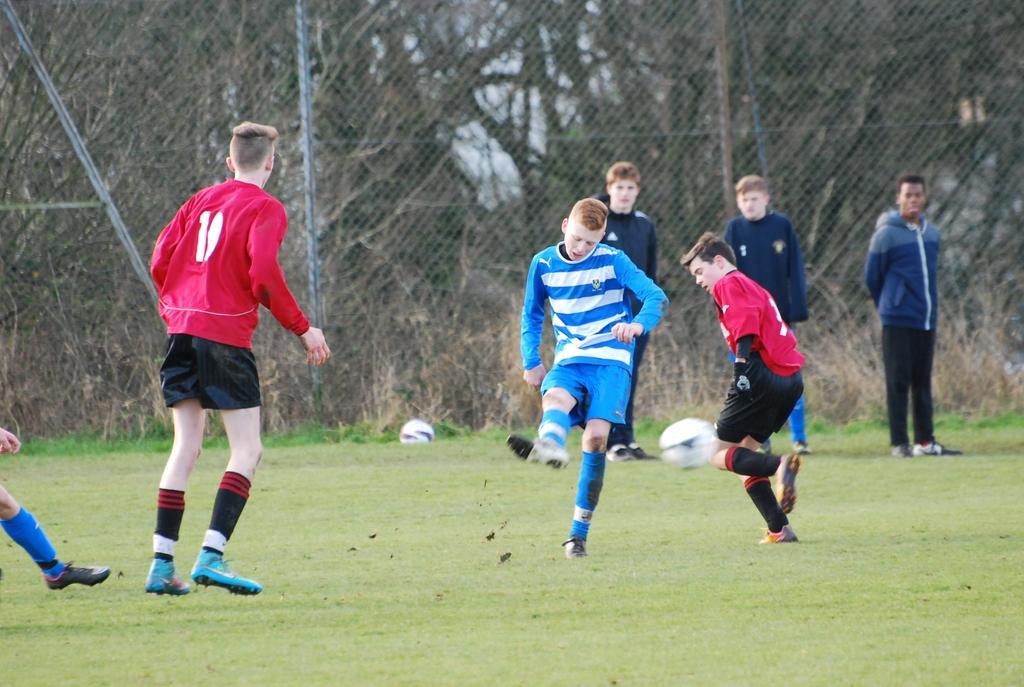In one or two sentences, can you explain what this image depicts? This three persons are walking as there is a leg movement. Far there are number of bare trees. The grass is in green color. This is ball. This three persons are standing. 